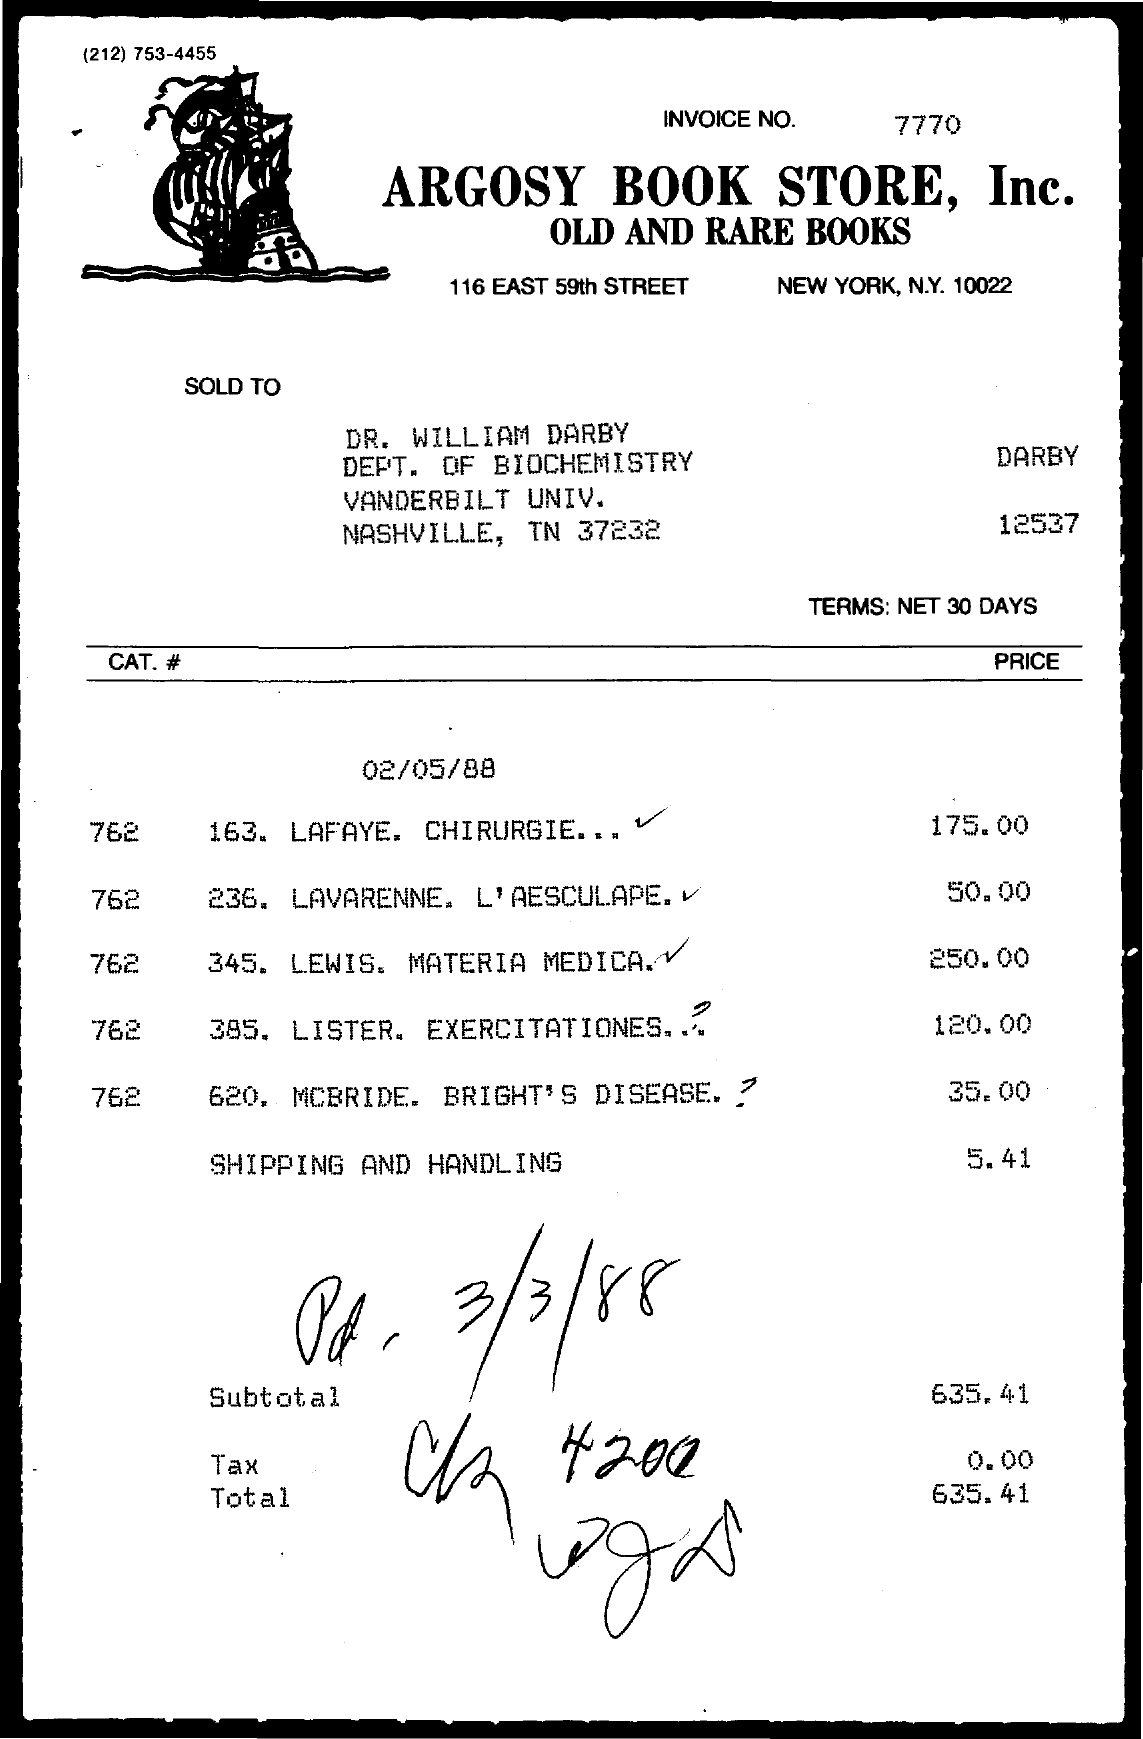Indicate a few pertinent items in this graphic. What is the invoice number? It is 7770... 